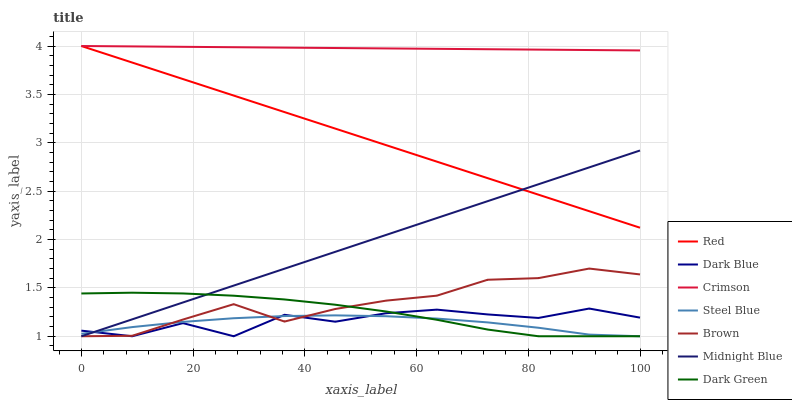Does Steel Blue have the minimum area under the curve?
Answer yes or no. Yes. Does Crimson have the maximum area under the curve?
Answer yes or no. Yes. Does Midnight Blue have the minimum area under the curve?
Answer yes or no. No. Does Midnight Blue have the maximum area under the curve?
Answer yes or no. No. Is Midnight Blue the smoothest?
Answer yes or no. Yes. Is Dark Blue the roughest?
Answer yes or no. Yes. Is Steel Blue the smoothest?
Answer yes or no. No. Is Steel Blue the roughest?
Answer yes or no. No. Does Brown have the lowest value?
Answer yes or no. Yes. Does Crimson have the lowest value?
Answer yes or no. No. Does Red have the highest value?
Answer yes or no. Yes. Does Midnight Blue have the highest value?
Answer yes or no. No. Is Dark Blue less than Crimson?
Answer yes or no. Yes. Is Red greater than Steel Blue?
Answer yes or no. Yes. Does Steel Blue intersect Dark Green?
Answer yes or no. Yes. Is Steel Blue less than Dark Green?
Answer yes or no. No. Is Steel Blue greater than Dark Green?
Answer yes or no. No. Does Dark Blue intersect Crimson?
Answer yes or no. No. 